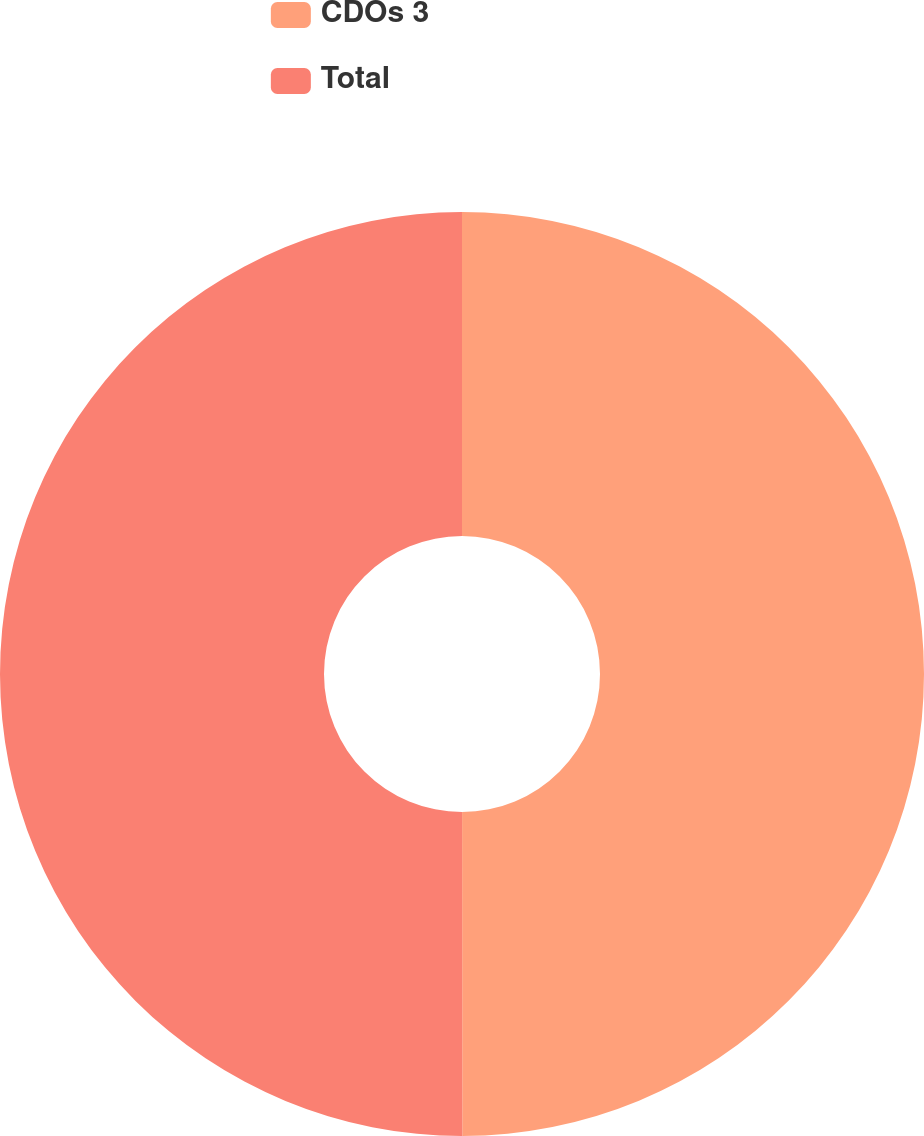<chart> <loc_0><loc_0><loc_500><loc_500><pie_chart><fcel>CDOs 3<fcel>Total<nl><fcel>49.99%<fcel>50.01%<nl></chart> 